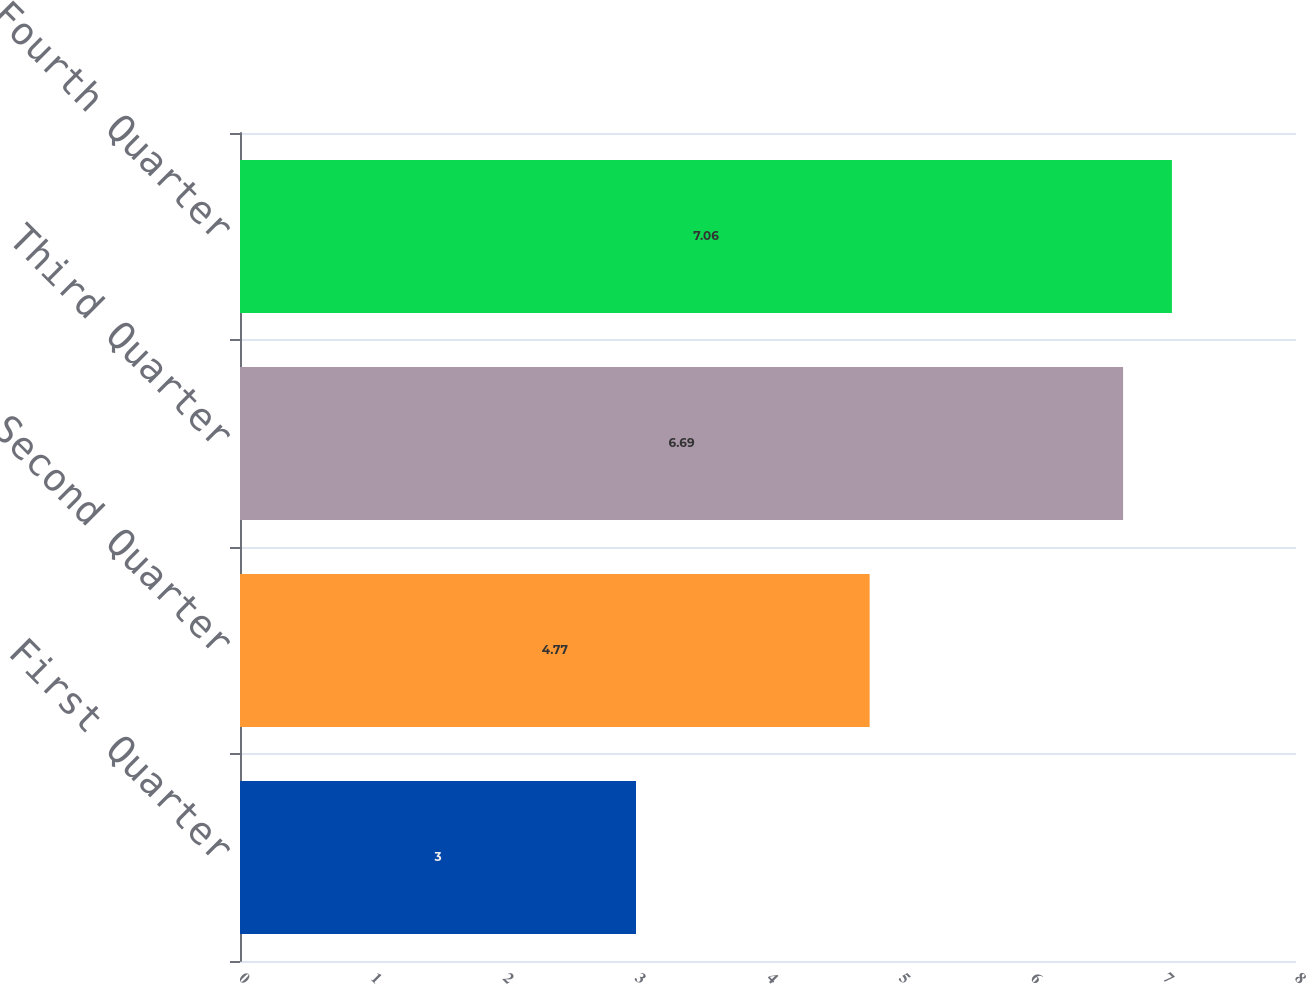Convert chart to OTSL. <chart><loc_0><loc_0><loc_500><loc_500><bar_chart><fcel>First Quarter<fcel>Second Quarter<fcel>Third Quarter<fcel>Fourth Quarter<nl><fcel>3<fcel>4.77<fcel>6.69<fcel>7.06<nl></chart> 